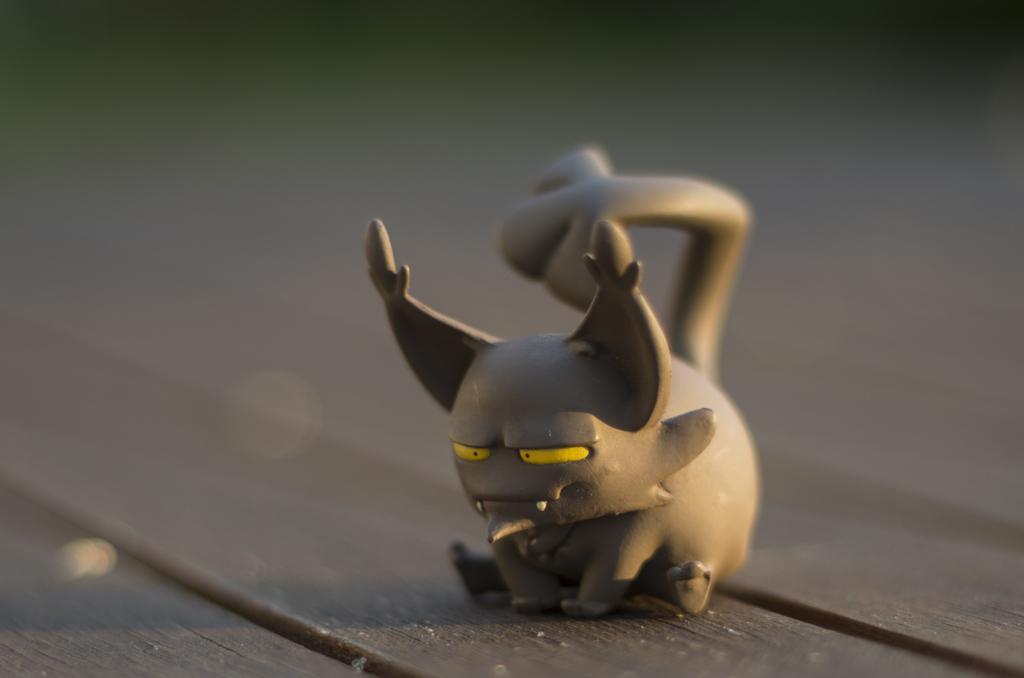In one or two sentences, can you explain what this image depicts? In the image we can see a toy, gray in color. This is a wooden surface and the background is blurred. 